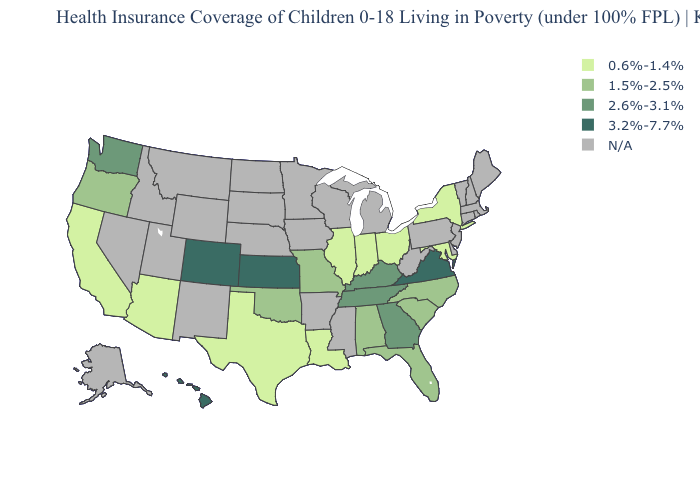Name the states that have a value in the range N/A?
Give a very brief answer. Alaska, Arkansas, Connecticut, Delaware, Idaho, Iowa, Maine, Massachusetts, Michigan, Minnesota, Mississippi, Montana, Nebraska, Nevada, New Hampshire, New Jersey, New Mexico, North Dakota, Pennsylvania, Rhode Island, South Dakota, Utah, Vermont, West Virginia, Wisconsin, Wyoming. Does the map have missing data?
Be succinct. Yes. Name the states that have a value in the range 0.6%-1.4%?
Concise answer only. Arizona, California, Illinois, Indiana, Louisiana, Maryland, New York, Ohio, Texas. Name the states that have a value in the range 0.6%-1.4%?
Quick response, please. Arizona, California, Illinois, Indiana, Louisiana, Maryland, New York, Ohio, Texas. What is the value of Iowa?
Short answer required. N/A. Does the first symbol in the legend represent the smallest category?
Short answer required. Yes. What is the value of Georgia?
Write a very short answer. 2.6%-3.1%. Name the states that have a value in the range 0.6%-1.4%?
Quick response, please. Arizona, California, Illinois, Indiana, Louisiana, Maryland, New York, Ohio, Texas. How many symbols are there in the legend?
Quick response, please. 5. What is the value of Colorado?
Answer briefly. 3.2%-7.7%. What is the value of Texas?
Be succinct. 0.6%-1.4%. Among the states that border Georgia , does Tennessee have the lowest value?
Answer briefly. No. 